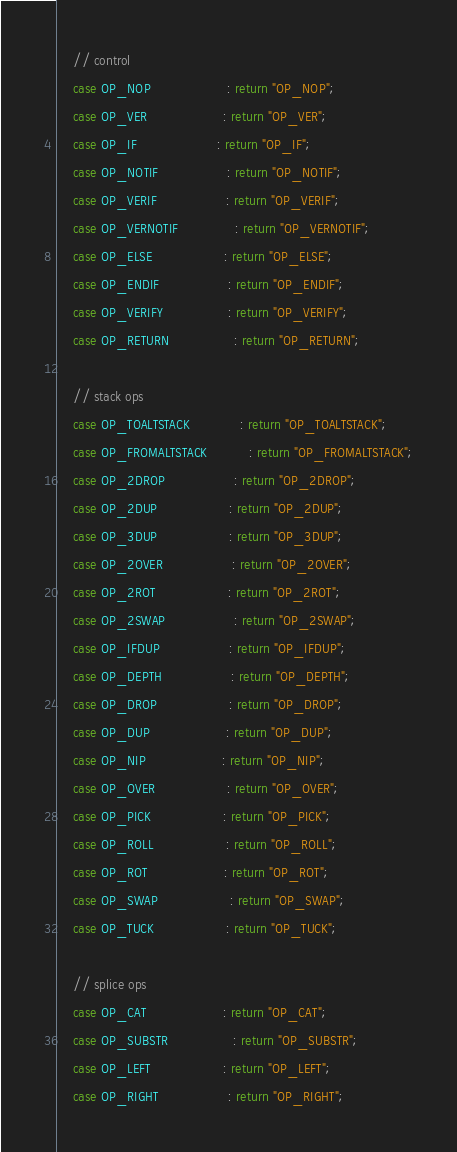<code> <loc_0><loc_0><loc_500><loc_500><_C++_>
    // control
    case OP_NOP                    : return "OP_NOP";
    case OP_VER                    : return "OP_VER";
    case OP_IF                     : return "OP_IF";
    case OP_NOTIF                  : return "OP_NOTIF";
    case OP_VERIF                  : return "OP_VERIF";
    case OP_VERNOTIF               : return "OP_VERNOTIF";
    case OP_ELSE                   : return "OP_ELSE";
    case OP_ENDIF                  : return "OP_ENDIF";
    case OP_VERIFY                 : return "OP_VERIFY";
    case OP_RETURN                 : return "OP_RETURN";

    // stack ops
    case OP_TOALTSTACK             : return "OP_TOALTSTACK";
    case OP_FROMALTSTACK           : return "OP_FROMALTSTACK";
    case OP_2DROP                  : return "OP_2DROP";
    case OP_2DUP                   : return "OP_2DUP";
    case OP_3DUP                   : return "OP_3DUP";
    case OP_2OVER                  : return "OP_2OVER";
    case OP_2ROT                   : return "OP_2ROT";
    case OP_2SWAP                  : return "OP_2SWAP";
    case OP_IFDUP                  : return "OP_IFDUP";
    case OP_DEPTH                  : return "OP_DEPTH";
    case OP_DROP                   : return "OP_DROP";
    case OP_DUP                    : return "OP_DUP";
    case OP_NIP                    : return "OP_NIP";
    case OP_OVER                   : return "OP_OVER";
    case OP_PICK                   : return "OP_PICK";
    case OP_ROLL                   : return "OP_ROLL";
    case OP_ROT                    : return "OP_ROT";
    case OP_SWAP                   : return "OP_SWAP";
    case OP_TUCK                   : return "OP_TUCK";

    // splice ops
    case OP_CAT                    : return "OP_CAT";
    case OP_SUBSTR                 : return "OP_SUBSTR";
    case OP_LEFT                   : return "OP_LEFT";
    case OP_RIGHT                  : return "OP_RIGHT";</code> 